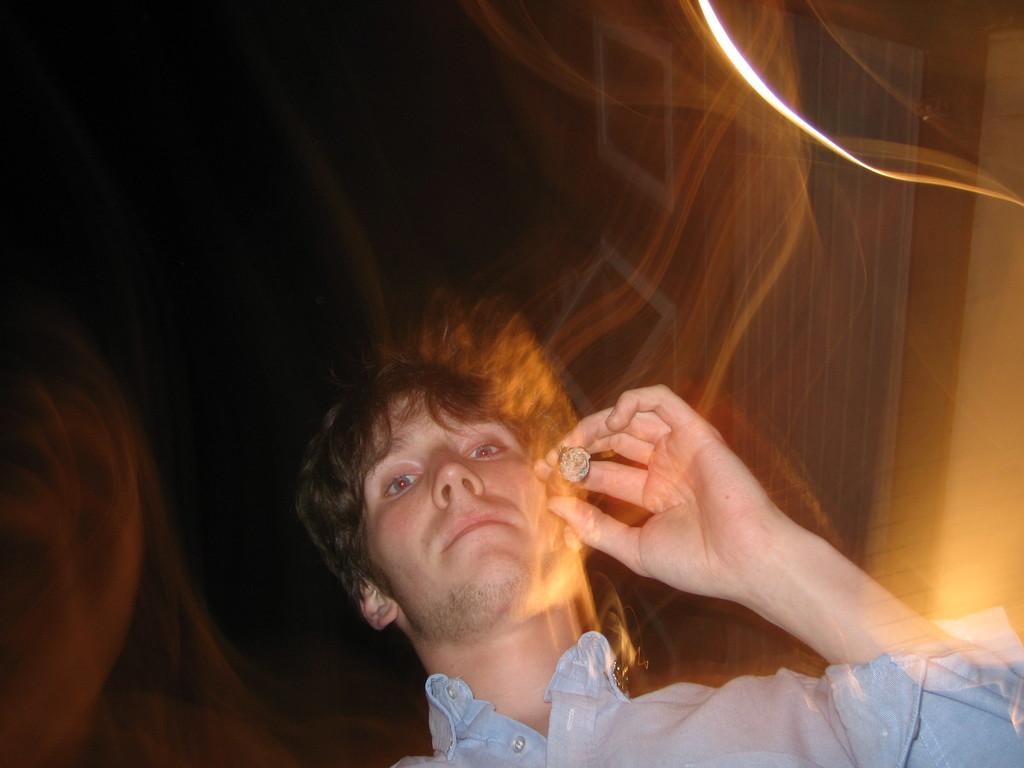Who is present in the image? There is a man in the image. What is the man wearing? The man is wearing a shirt. What is the man holding in his hand? The man is holding a cigar in his hand. What can be observed about the background of the image? The background of the image is dark. What is visible in the image that is related to the cigar? There is smoke visible in the image. What type of sand can be seen in the image? There is no sand present in the image. How does the man's behavior change throughout the image? The image is a still photograph, so it does not show any changes in the man's behavior over time. 